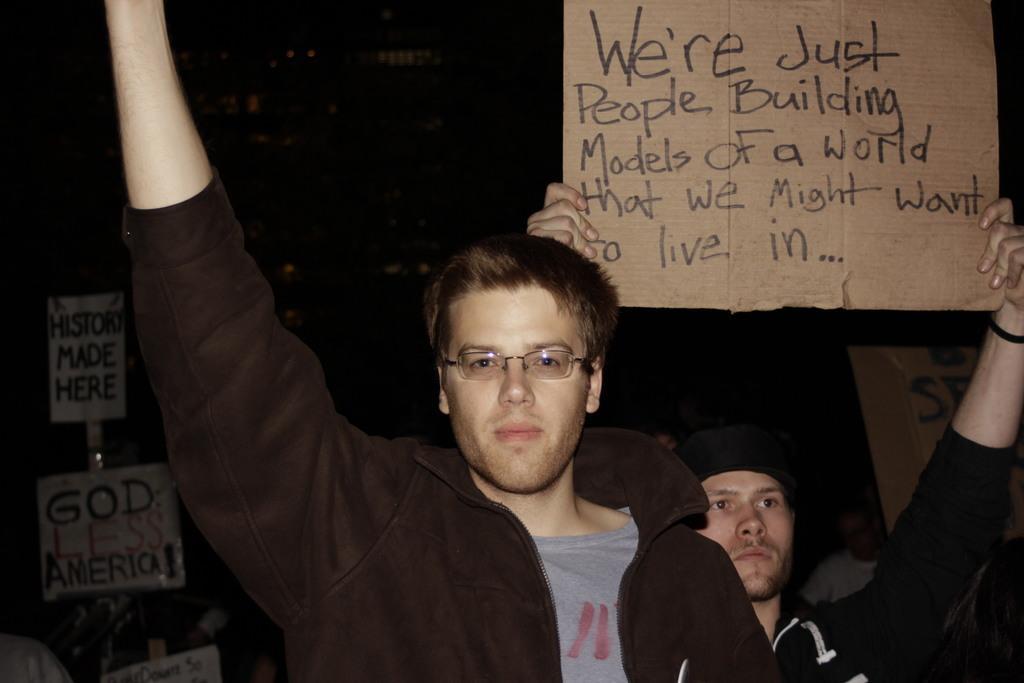Could you give a brief overview of what you see in this image? In this image I can see in the middle a man is raising his hand, he wore brown color sweater, grey color t-shirt and spectacles. Behind him there is another man holding the placard in his hands, he wore cap, sweater. On the left side there are placards in this image. 